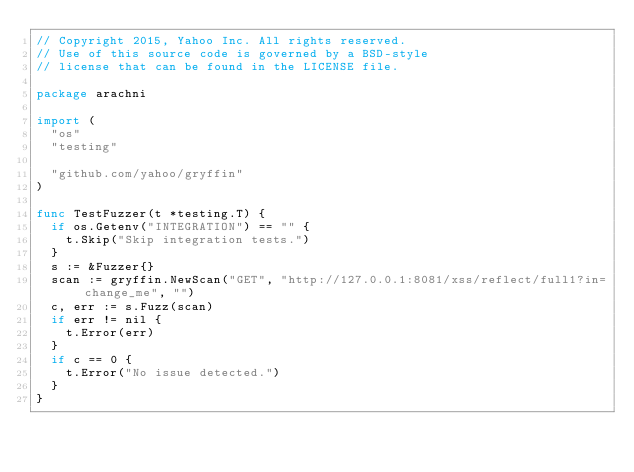<code> <loc_0><loc_0><loc_500><loc_500><_Go_>// Copyright 2015, Yahoo Inc. All rights reserved.
// Use of this source code is governed by a BSD-style
// license that can be found in the LICENSE file.

package arachni

import (
	"os"
	"testing"

	"github.com/yahoo/gryffin"
)

func TestFuzzer(t *testing.T) {
	if os.Getenv("INTEGRATION") == "" {
		t.Skip("Skip integration tests.")
	}
	s := &Fuzzer{}
	scan := gryffin.NewScan("GET", "http://127.0.0.1:8081/xss/reflect/full1?in=change_me", "")
	c, err := s.Fuzz(scan)
	if err != nil {
		t.Error(err)
	}
	if c == 0 {
		t.Error("No issue detected.")
	}
}
</code> 